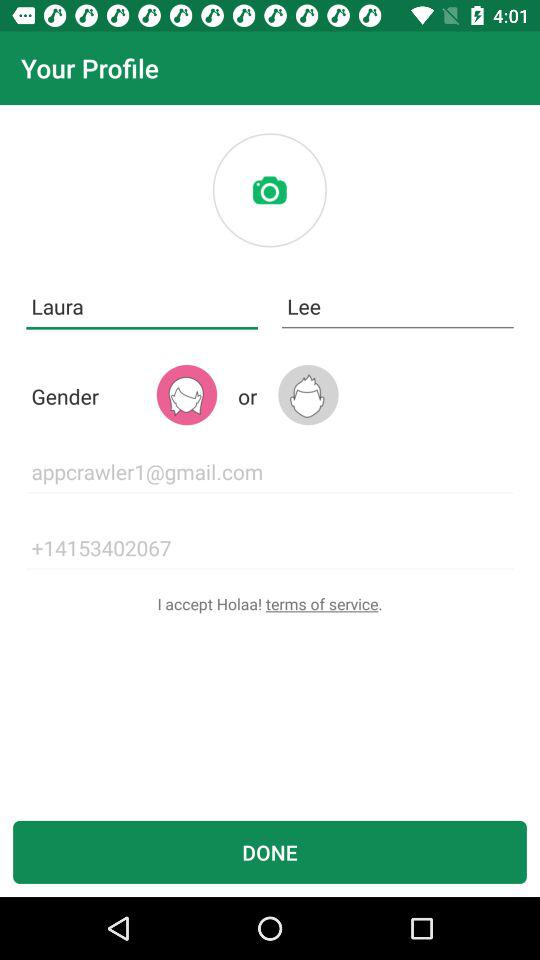What is the gender of the user? The gender of the user is female. 